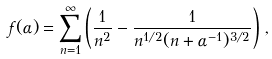Convert formula to latex. <formula><loc_0><loc_0><loc_500><loc_500>f ( \alpha ) = \sum _ { n = 1 } ^ { \infty } \left ( \frac { 1 } { n ^ { 2 } } - \frac { 1 } { n ^ { 1 / 2 } ( n + \alpha ^ { - 1 } ) ^ { 3 / 2 } } \right ) \, ,</formula> 